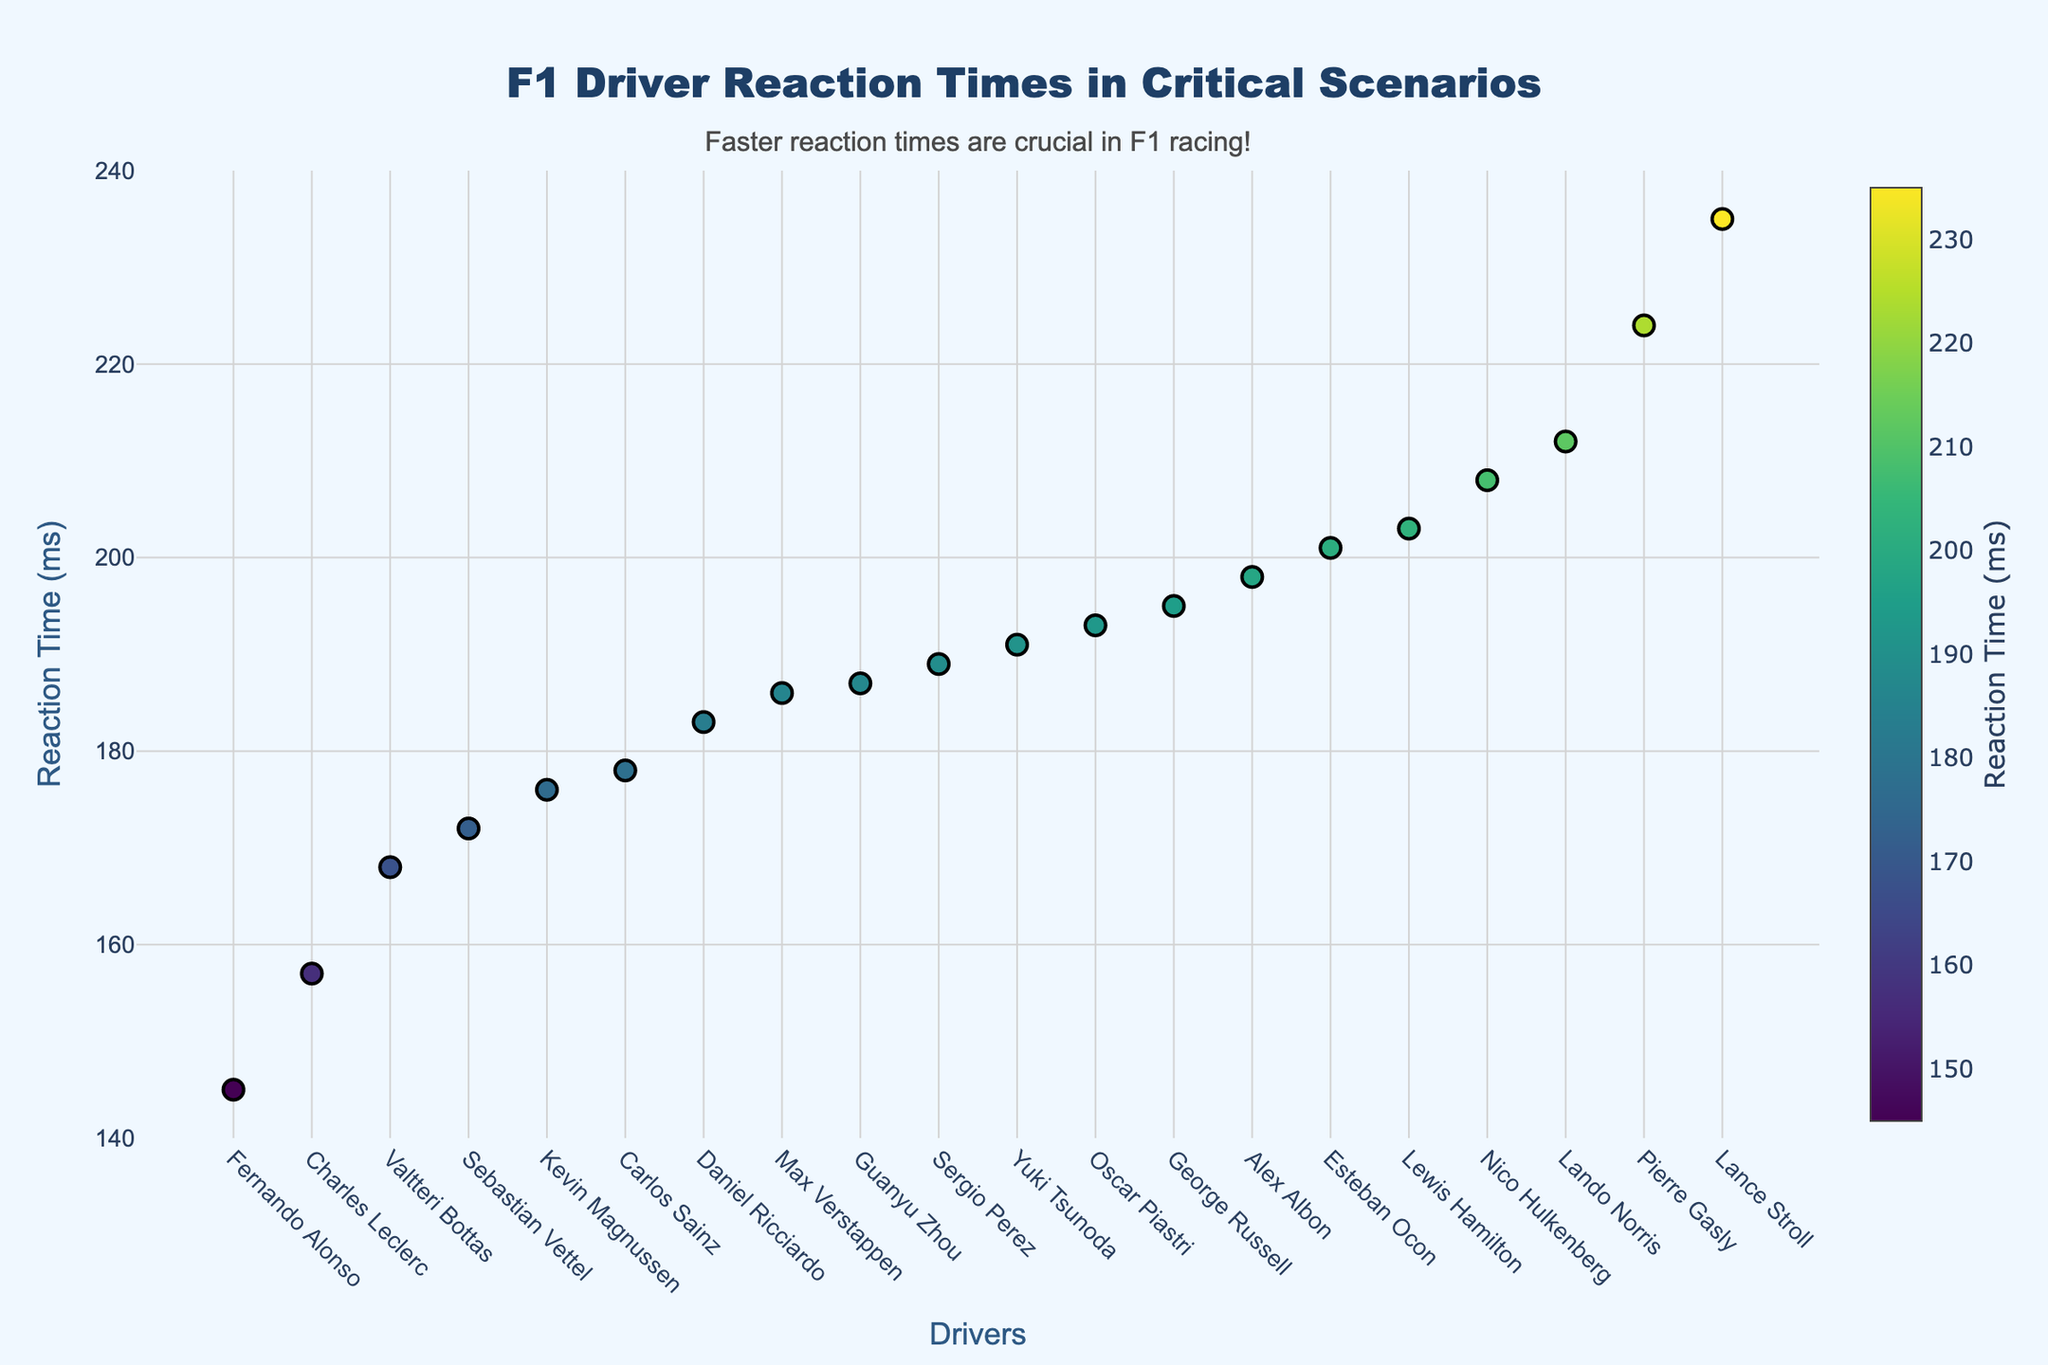What is the title of the plot? The title is usually displayed at the top of the plot. In this case, the title is written in large fonts as "F1 Driver Reaction Times in Critical Scenarios".
Answer: F1 Driver Reaction Times in Critical Scenarios Which driver has the fastest reaction time? The fastest reaction time corresponds to the lowest value on the y-axis. Here, it would be the smallest dot on the y-axis. Fernando Alonso has the lowest value at 145 ms.
Answer: Fernando Alonso How many drivers are represented in the plot? Each driver is represented by a data point on the x-axis. Counting the unique names on the x-axis gives us this number. Here, it appears there are 20 drivers listed on the x-axis.
Answer: 20 What is the reaction time for Charles Leclerc? By locating Charles Leclerc on the x-axis and looking up his corresponding y-value, we see his reaction time. The plot indicates it is 157 milliseconds.
Answer: 157 milliseconds Which reaction scenario has the highest reaction time? The y-axis represents reaction time, and the highest point on the y-axis will show the largest reaction time. The scenario corresponding to this point is "Aquaplaning Recovery" by Lance Stroll with 235 ms.
Answer: Aquaplaning Recovery What is the median reaction time of all drivers? To find the median, we list the reaction times in ascending order and pick the middle value. For 20 data points, it's an average of the 10th and 11th values. Sorting the values, the 10th and 11th are 191 ms and 193 ms, so median is (191+193)/2=192 ms.
Answer: 192 milliseconds Which driver had the slowest reaction time in a sudden car ahead braking scenario? Identify the reaction time by locating the scenario on the figure. Yuki Tsunoda is the driver, with a reaction time of 191 ms in the "Sudden Car Ahead Braking" scenario.
Answer: Yuki Tsunoda Compare the reaction times between Max Verstappen and Lewis Hamilton, and determine who was faster. Max Verstappen appears on the left with a y-value of 186 ms, whereas Lewis Hamilton is further right with a y-value of 203 ms. Lower value indicates faster reaction.
Answer: Max Verstappen Calculate the range of reaction times across all drivers. The range is the difference between the maximum and minimum reaction times. The maximum is 235 ms (Lance Stroll), and the minimum is 145 ms (Fernando Alonso). Range = 235 - 145 = 90 ms.
Answer: 90 milliseconds Which driver shows a reaction time around 200 milliseconds? Searching for a y-value close to 200 ms, we see several points. Esteban Ocon at 201 ms and Alex Albon at 198 ms are the nearest to 200 ms.
Answer: Esteban Ocon, Alex Albon 